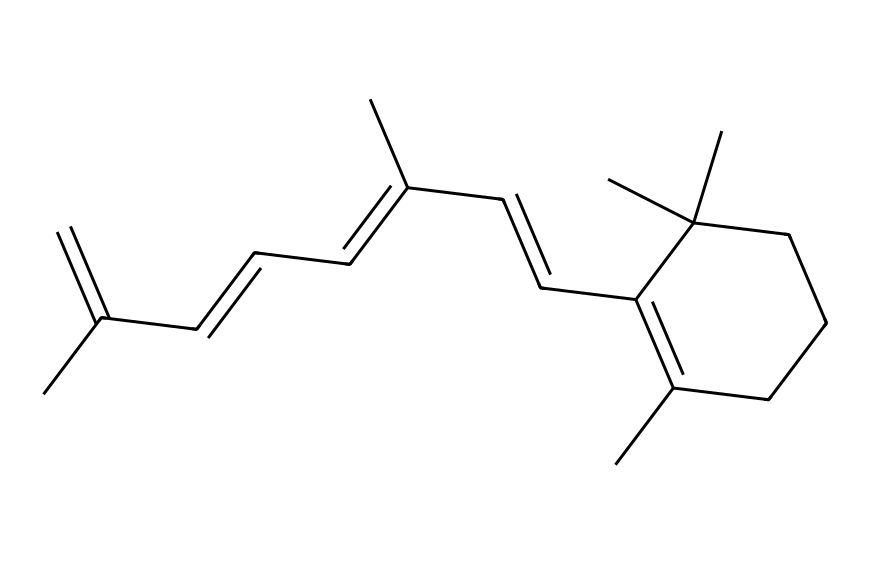What is the molecular formula of retinol? To determine the molecular formula, we analyze the structure represented by the provided SMILES. Each capital letter signifies an atom (such as C for carbon and H for hydrogen), and we count these accordingly. The structure indicates that there are 20 carbon atoms and 30 hydrogen atoms, so the molecular formula is C20H30.
Answer: C20H30 How many double bonds are present in the retinol structure? In the provided SMILES, we look for instances of double bonds indicated by the '=' sign. By examining the structure, we can identify a total of 4 double bonds located at specific positions in the hydrocarbon chain.
Answer: 4 What is the significance of the hydroxyl group in retinol? The presence of the hydroxyl group indicates that retinol is an alcohol, which contributes to its polarity and ability to interact with skin tissues. In the structure, the hydroxyl group also helps in the biological activity of retinol, particularly in promoting skin health and regeneration.
Answer: alcohol Why might retinol be effective for anti-aging? Retinol is known for its ability to promote cell turnover and stimulate collagen production, which are essential processes for maintaining skin elasticity and reducing wrinkles. The presence of the full carbon backbone, including the double bonds, contributes to the stability and effectiveness of retinol in skincare formulations.
Answer: cell turnover Is retinol classified as an imide? Retinol does not contain the characteristic imide functional group, which consists of a carbonyl group adjacent to a nitrogen atom. Instead, it is classified as a vitamin A derivative, specifically an alcohol. Thus, it does not fit the criteria for imides.
Answer: No 